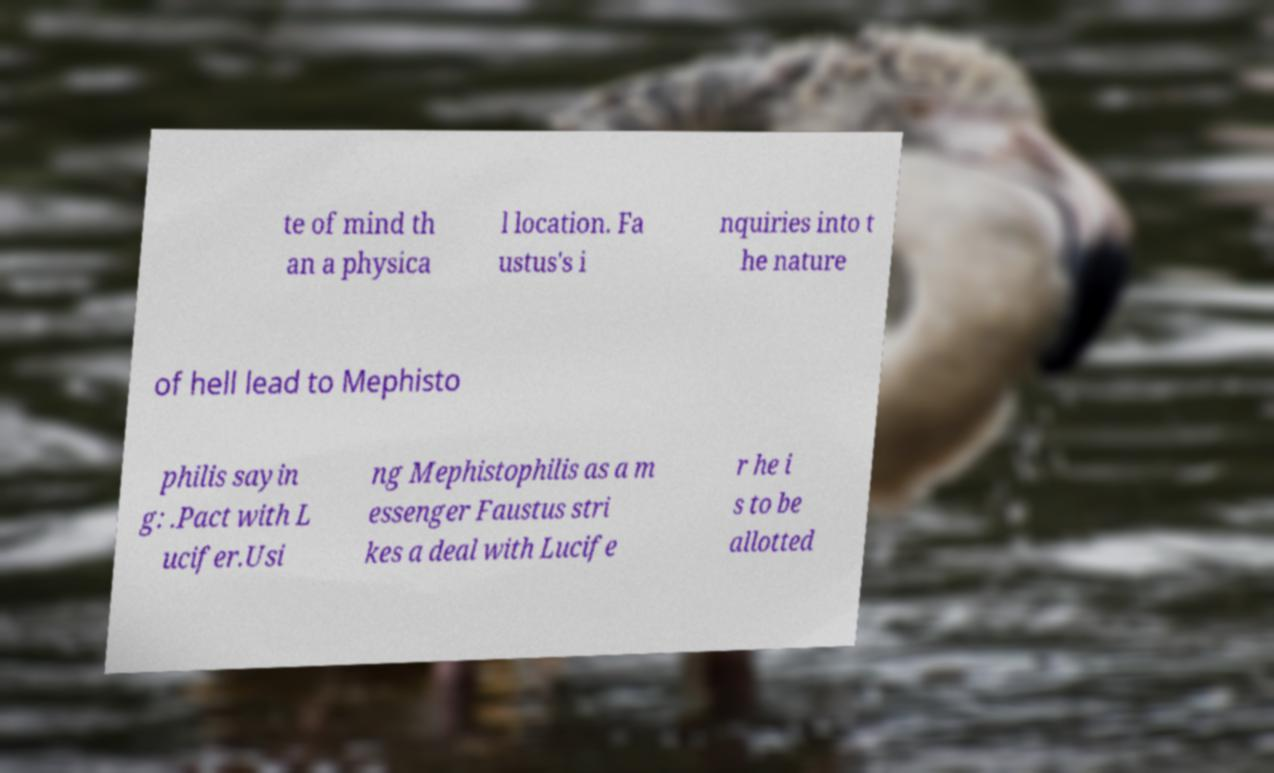Can you accurately transcribe the text from the provided image for me? te of mind th an a physica l location. Fa ustus's i nquiries into t he nature of hell lead to Mephisto philis sayin g: .Pact with L ucifer.Usi ng Mephistophilis as a m essenger Faustus stri kes a deal with Lucife r he i s to be allotted 